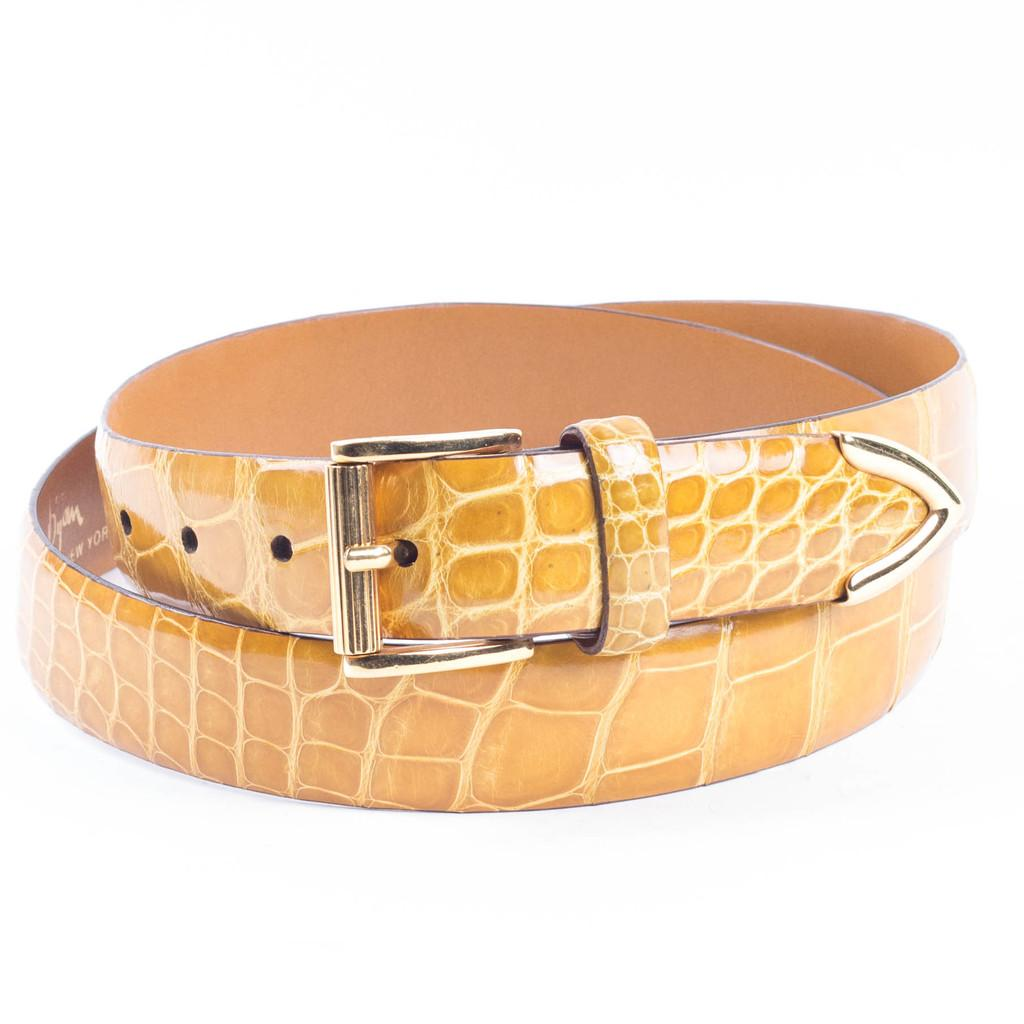What object can be seen in the image? There is a belt in the image. What is the color of the background in the image? There is a white background in the image. What type of net can be seen in the image? There is no net present in the image; it only features a belt on a white background. 